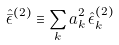<formula> <loc_0><loc_0><loc_500><loc_500>\hat { \bar { \epsilon } } ^ { ( 2 ) } \equiv \sum _ { k } a _ { k } ^ { 2 } \, \hat { \epsilon } _ { k } ^ { ( 2 ) }</formula> 